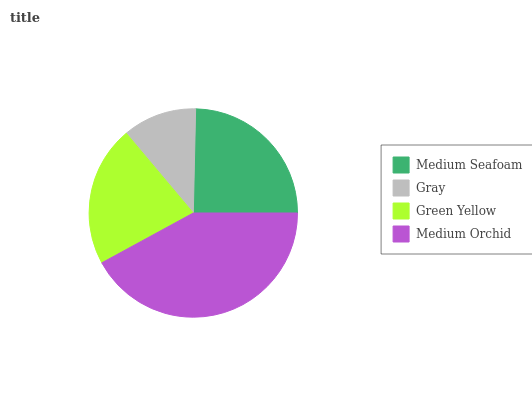Is Gray the minimum?
Answer yes or no. Yes. Is Medium Orchid the maximum?
Answer yes or no. Yes. Is Green Yellow the minimum?
Answer yes or no. No. Is Green Yellow the maximum?
Answer yes or no. No. Is Green Yellow greater than Gray?
Answer yes or no. Yes. Is Gray less than Green Yellow?
Answer yes or no. Yes. Is Gray greater than Green Yellow?
Answer yes or no. No. Is Green Yellow less than Gray?
Answer yes or no. No. Is Medium Seafoam the high median?
Answer yes or no. Yes. Is Green Yellow the low median?
Answer yes or no. Yes. Is Medium Orchid the high median?
Answer yes or no. No. Is Gray the low median?
Answer yes or no. No. 